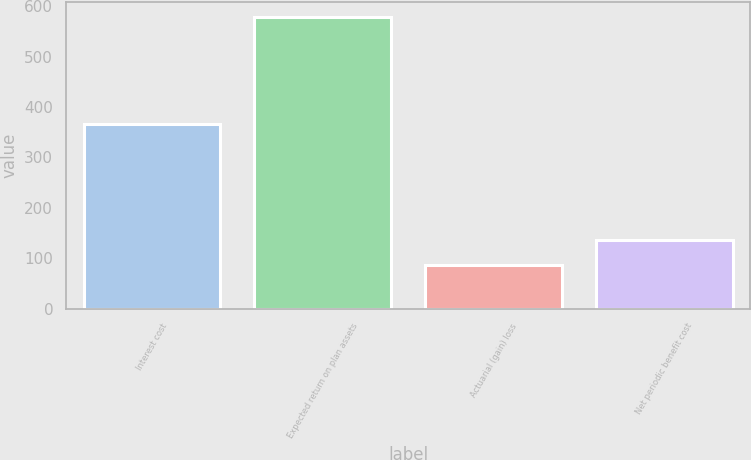<chart> <loc_0><loc_0><loc_500><loc_500><bar_chart><fcel>Interest cost<fcel>Expected return on plan assets<fcel>Actuarial (gain) loss<fcel>Net periodic benefit cost<nl><fcel>366<fcel>579<fcel>87<fcel>136.2<nl></chart> 